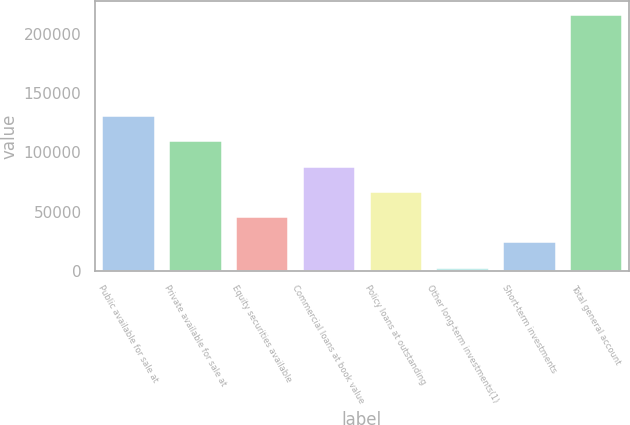Convert chart to OTSL. <chart><loc_0><loc_0><loc_500><loc_500><bar_chart><fcel>Public available for sale at<fcel>Private available for sale at<fcel>Equity securities available<fcel>Commercial loans at book value<fcel>Policy loans at outstanding<fcel>Other long-term investments(1)<fcel>Short-term investments<fcel>Total general account<nl><fcel>131501<fcel>110166<fcel>46161<fcel>88831<fcel>67496<fcel>3491<fcel>24826<fcel>216841<nl></chart> 